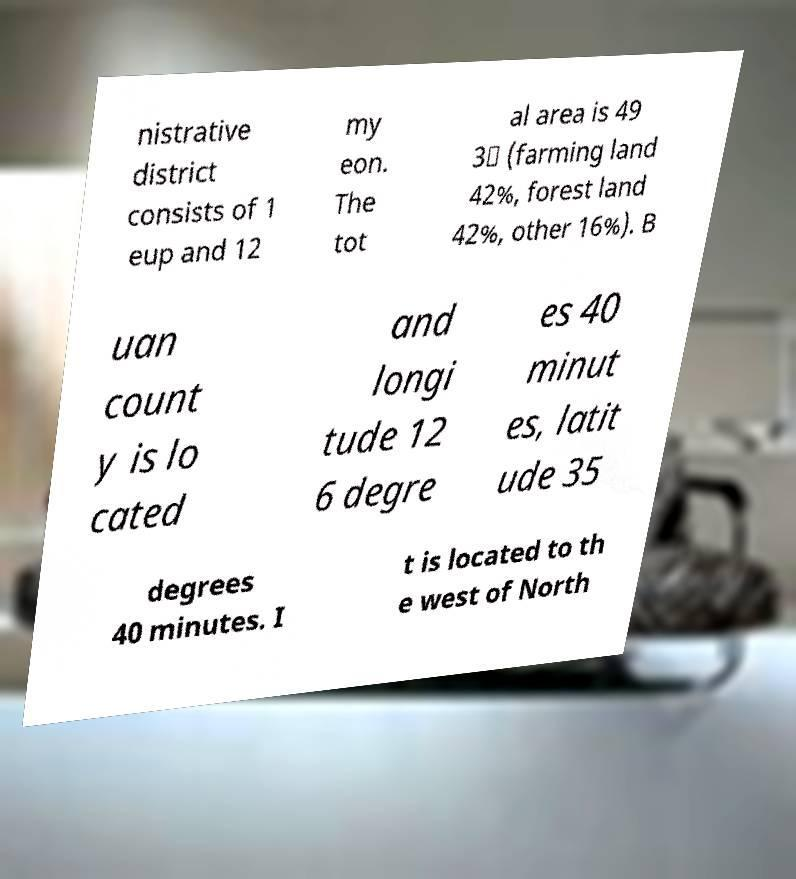Please identify and transcribe the text found in this image. nistrative district consists of 1 eup and 12 my eon. The tot al area is 49 3㎢ (farming land 42%, forest land 42%, other 16%). B uan count y is lo cated and longi tude 12 6 degre es 40 minut es, latit ude 35 degrees 40 minutes. I t is located to th e west of North 